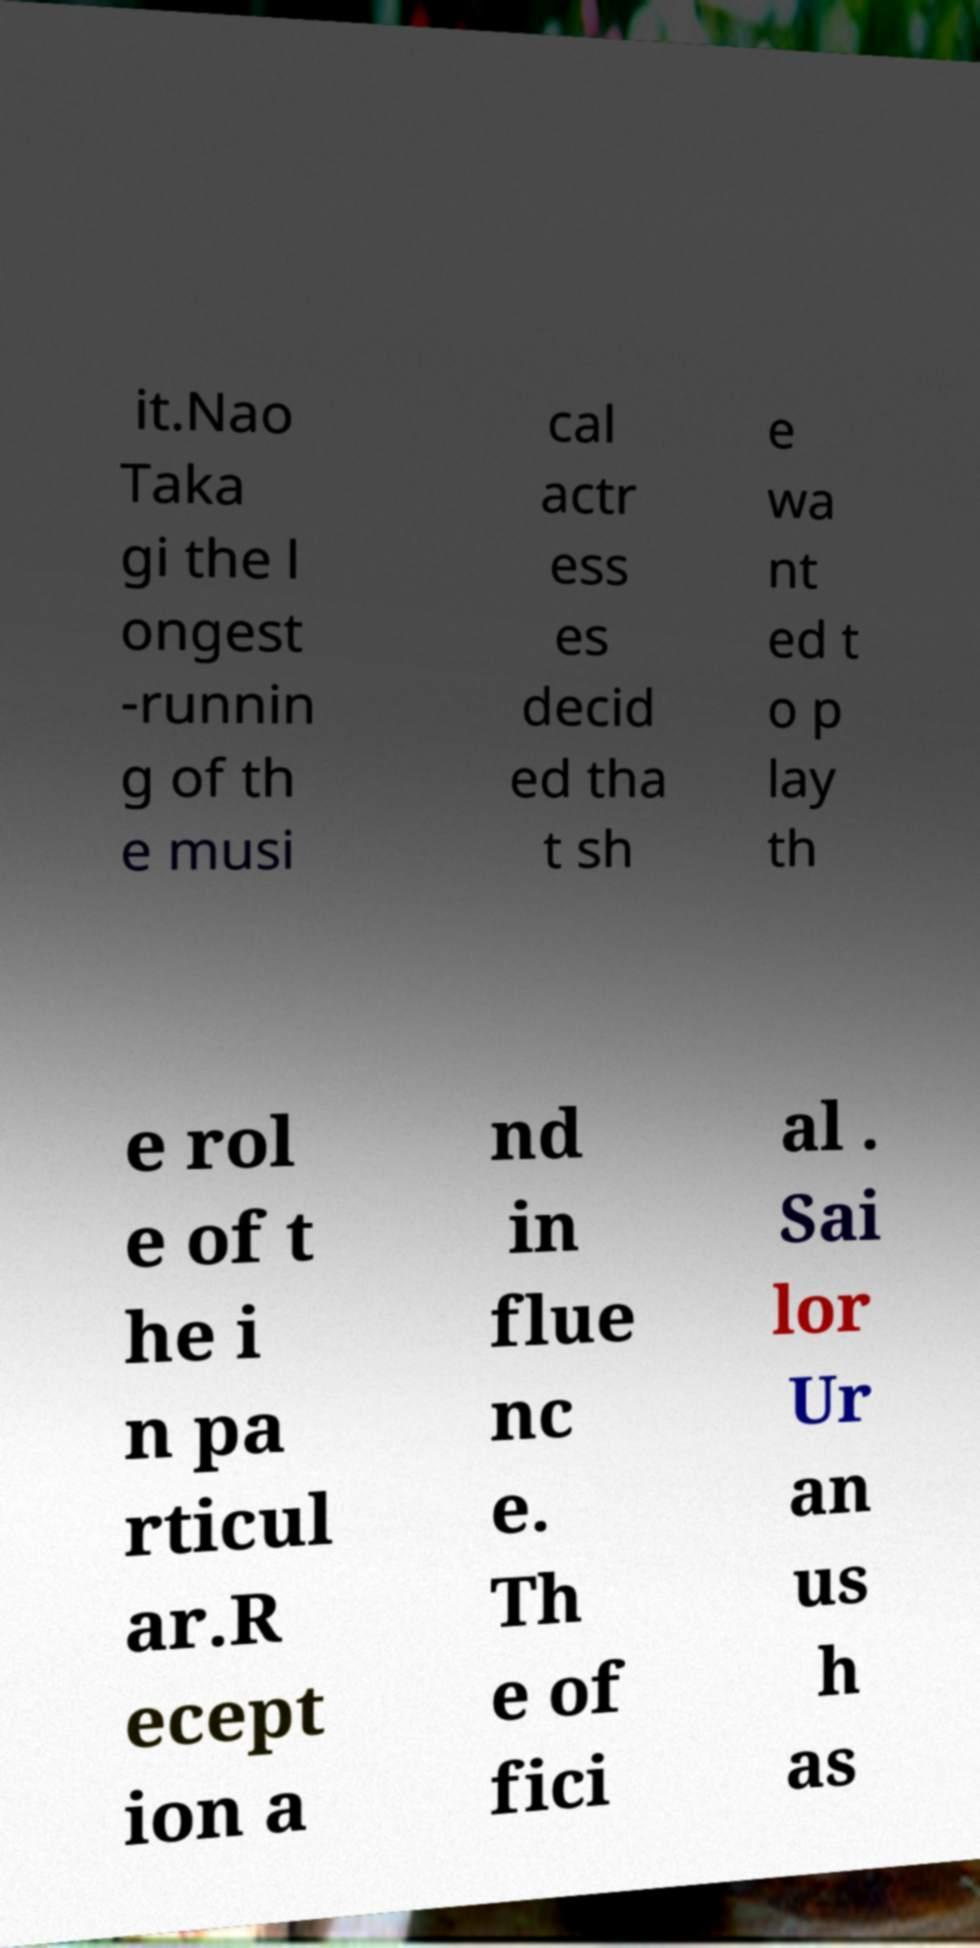Could you assist in decoding the text presented in this image and type it out clearly? it.Nao Taka gi the l ongest -runnin g of th e musi cal actr ess es decid ed tha t sh e wa nt ed t o p lay th e rol e of t he i n pa rticul ar.R ecept ion a nd in flue nc e. Th e of fici al . Sai lor Ur an us h as 